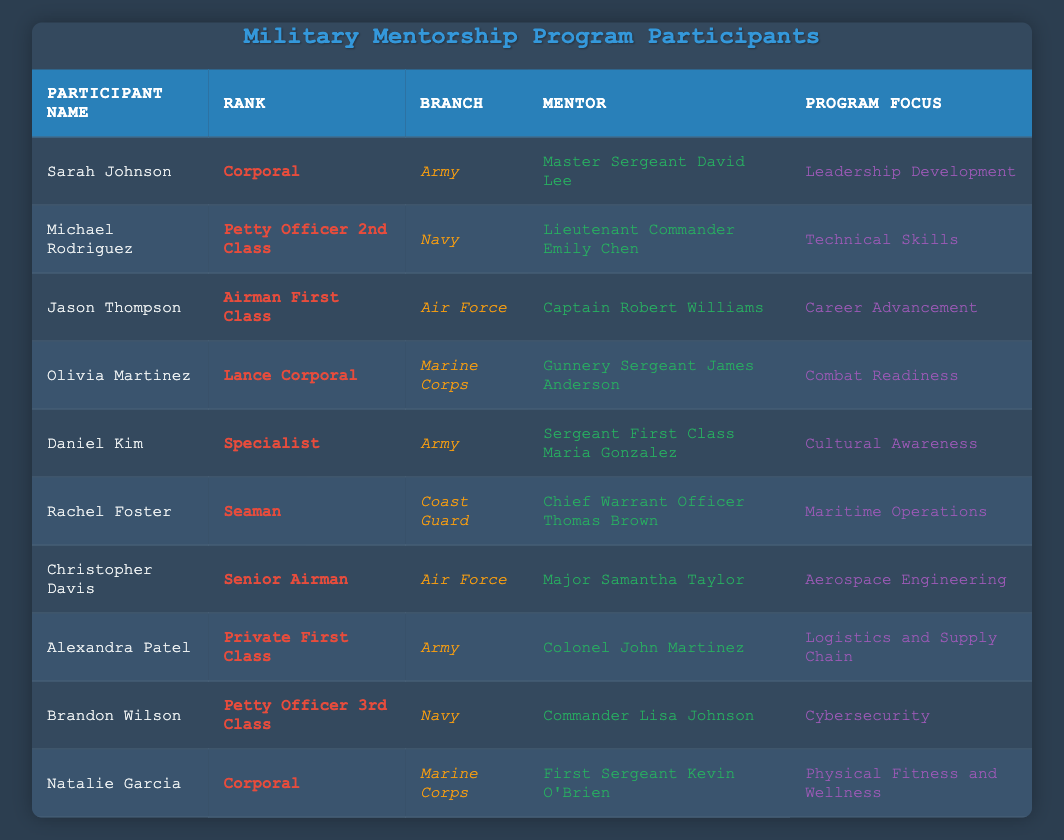What is the program focus of Sarah Johnson? Sarah Johnson's row shows that her program focus is "Leadership Development" in the table.
Answer: Leadership Development How many participants are in the Navy? The table shows two participants with the Navy branch: Michael Rodriguez and Brandon Wilson, so the count is 2.
Answer: 2 Who is Jason Thompson's mentor? Referring to Jason Thompson's row, it specifies that his mentor is "Captain Robert Williams."
Answer: Captain Robert Williams Is there any participant from the Coast Guard focusing on Maritime Operations? The table shows Rachel Foster from the Coast Guard with the program focus of "Maritime Operations," confirming that this is true.
Answer: Yes What are the ranks of participants focusing on Physical Fitness and Wellness and Cybersecurity? The table shows Natalie Garcia with the focus on "Physical Fitness and Wellness" is a Corporal, and Brandon Wilson with "Cybersecurity" is a Petty Officer 3rd Class.
Answer: Corporal and Petty Officer 3rd Class 